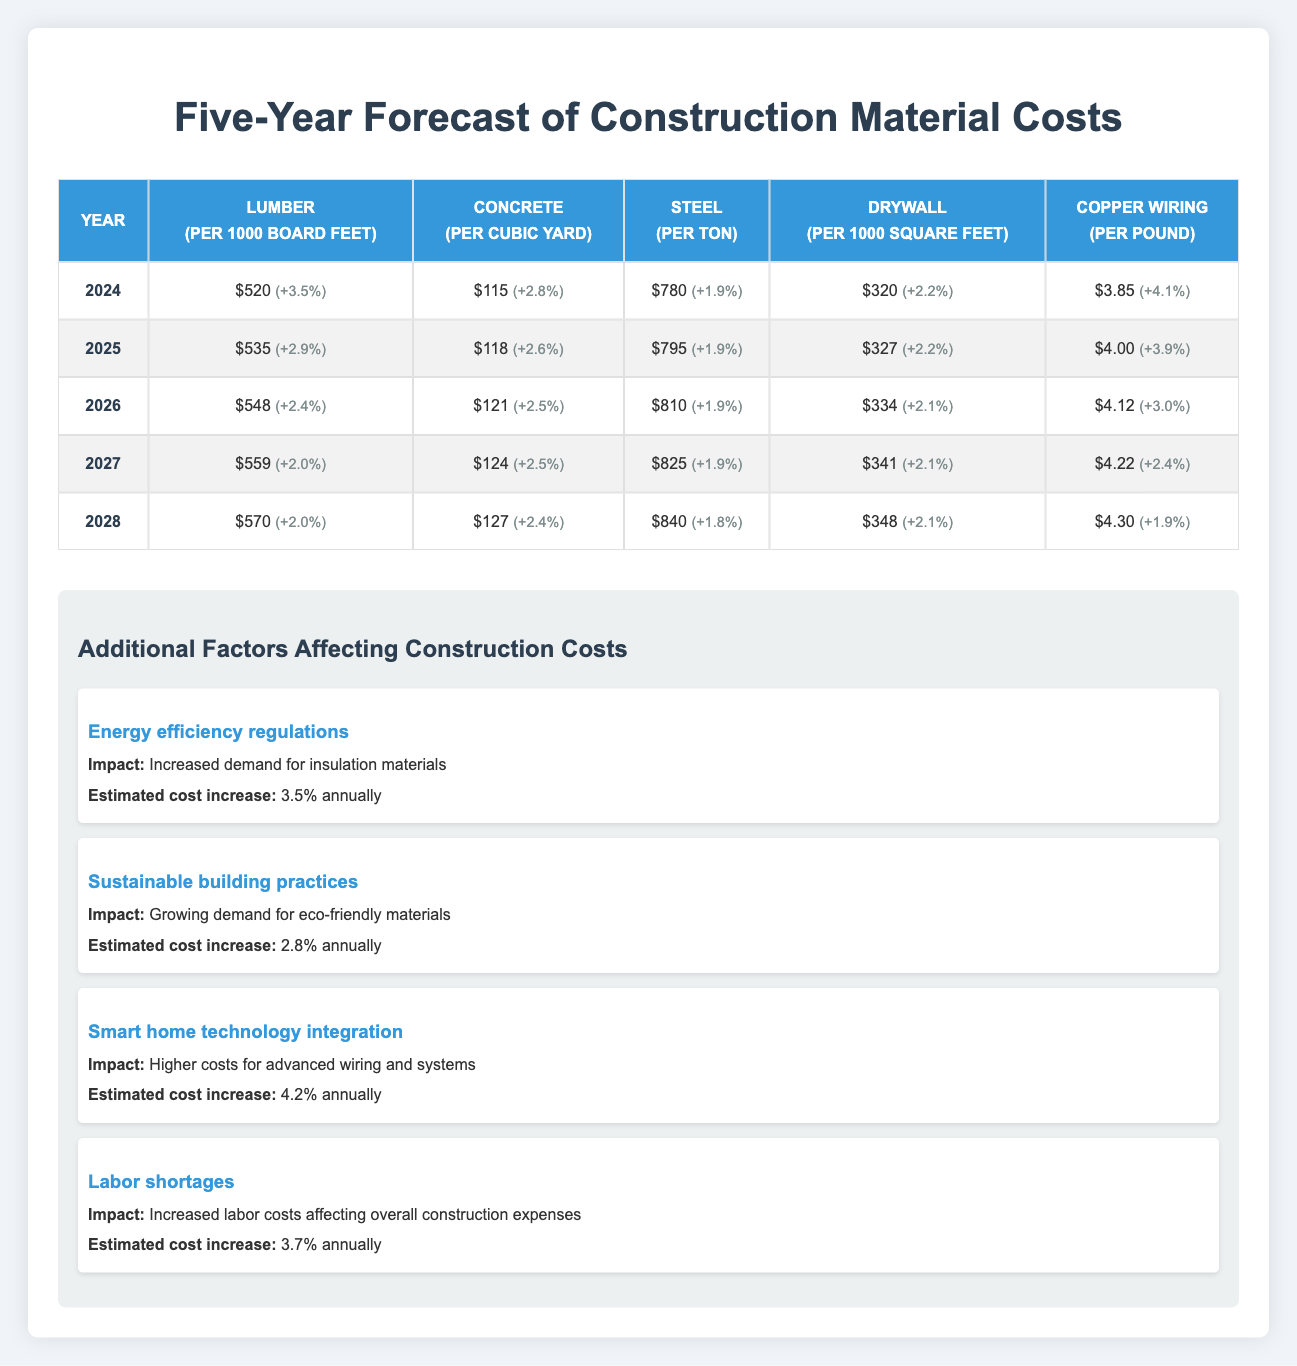What is the price of copper wiring in 2025? In the table under the year 2025, the price for copper wiring is listed as $4.00 per pound.
Answer: $4.00 What is the percent change for steel prices from 2024 to 2025? For steel in 2024, the percent change is +1.9%, and for 2025, it is also +1.9%. Since the percent change is the same for both years, the difference between them is 0.
Answer: 0% What is the overall price trend for drywall from 2024 to 2028? In 2024, drywall is priced at $320, and in 2028, it is priced at $348. To find the trend, calculate the percent change: ((348 - 320) / 320) * 100 = 8.75% over 4 years, which indicates a positive trend.
Answer: Increasing Is the price of concrete higher in 2026 compared to 2025? In the table, concrete is priced at $118 in 2025 and $121 in 2026, confirming that the price in 2026 is indeed higher than in 2025.
Answer: Yes What is the average price of lumber over the five years from 2024 to 2028? The prices for lumber are $520, $535, $548, $559, and $570 across the five years. To find the average, sum these values (520 + 535 + 548 + 559 + 570 = 2732) and divide by 5, giving an average of 546.4.
Answer: 546.4 What is the percent change in concrete prices from 2024 to 2028? The price of concrete in 2024 is $115, and in 2028 it is $127. The percent change is ((127 - 115) / 115) * 100 = 10.43%, indicating an increase in price over the four years.
Answer: 10.43% Did the price of copper wiring decrease from 2024 to 2028? The price of copper wiring was $3.85 in 2024 and $4.30 in 2028, which shows an increase rather than a decrease.
Answer: No What is the total percent change for drywall from 2024 to 2027? Drywall prices increase from $320 in 2024 to $341 in 2027. Thus, the percent change is ((341 - 320) / 320) * 100 = 6.56%, indicating an upward trend over three years.
Answer: 6.56% 